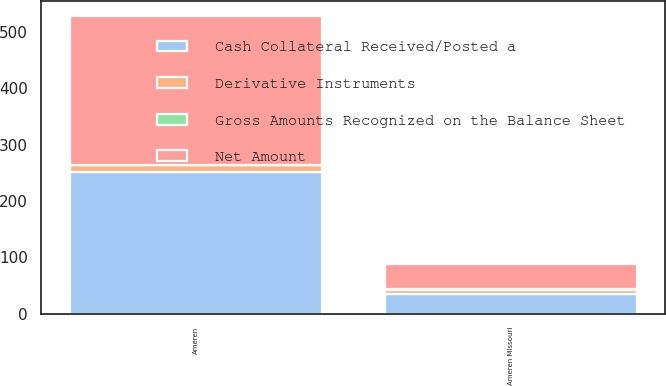Convert chart. <chart><loc_0><loc_0><loc_500><loc_500><stacked_bar_chart><ecel><fcel>Ameren Missouri<fcel>Ameren<nl><fcel>Net Amount<fcel>44<fcel>264<nl><fcel>Gross Amounts Recognized on the Balance Sheet<fcel>1<fcel>1<nl><fcel>Derivative Instruments<fcel>8<fcel>11<nl><fcel>Cash Collateral Received/Posted a<fcel>35<fcel>252<nl></chart> 